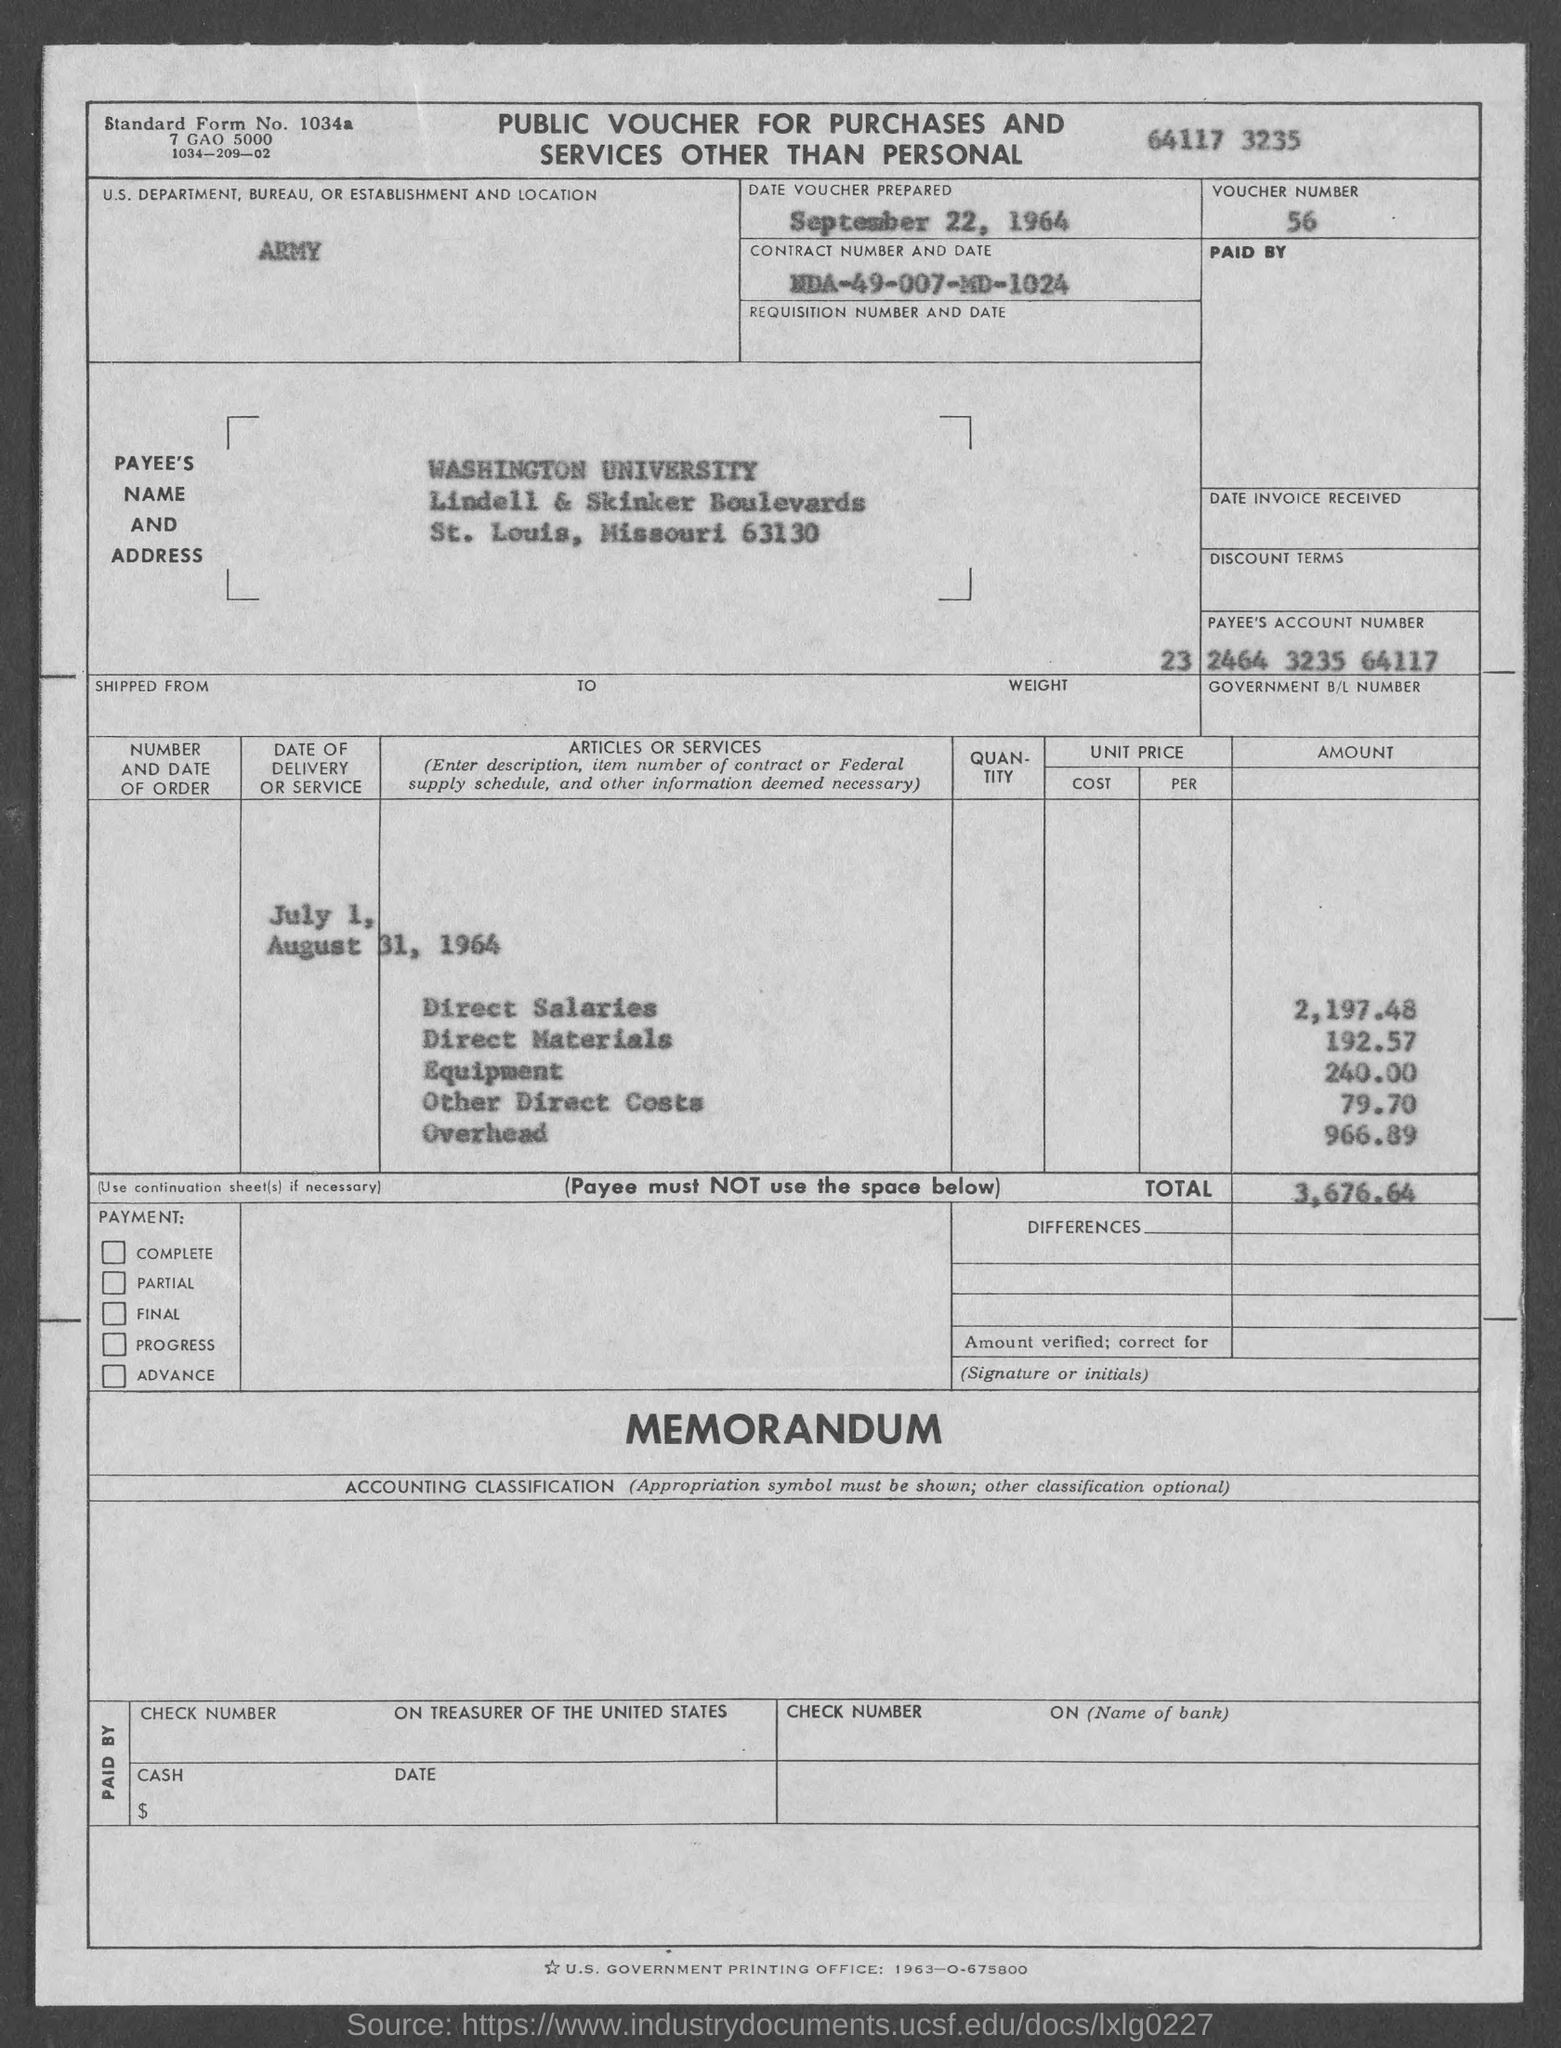Can you provide details on the total costs shown on this voucher? The total cost mentioned on this voucher amounts to $3,676.64, which includes Direct Salaries, Direct Materials, Other Direct Costs, and Overhead. 